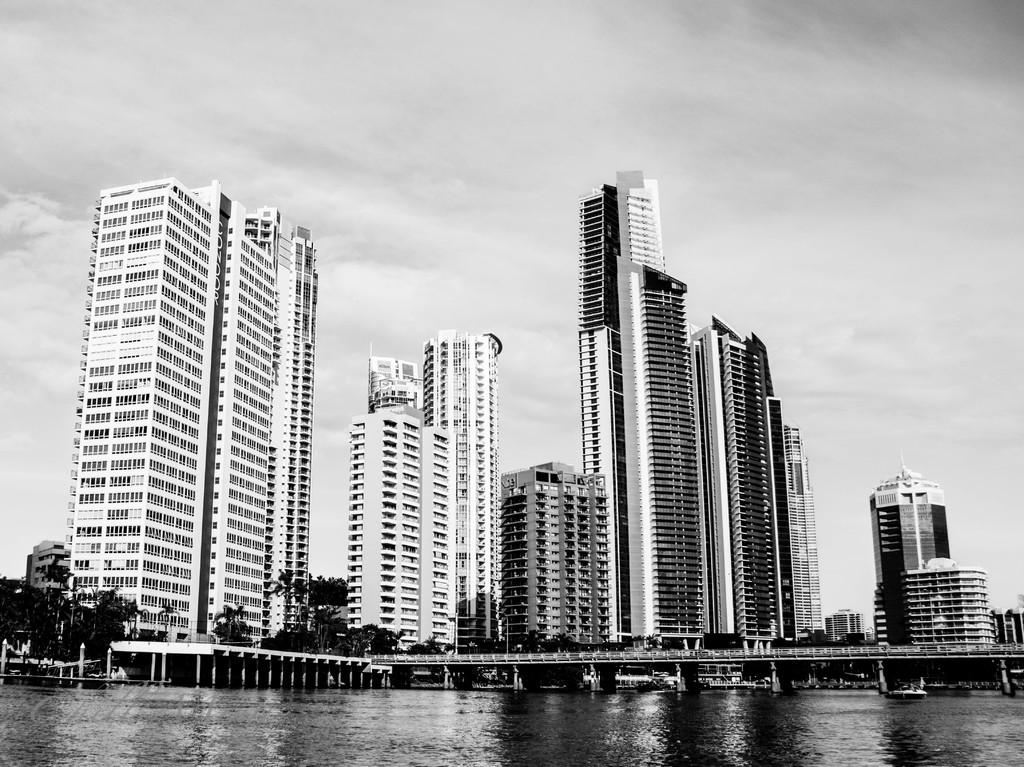What type of structures can be seen in the image? There are buildings in the image. What is located at the bottom of the image? There is water visible at the bottom of the image. What mode of transportation is present in the image? There is a boat in the image. What type of vegetation can be seen in the image? There are trees in the image. What is visible at the top of the image? The sky is visible at the top of the image. How many sheep are present in the image? There are no sheep present in the image. What type of cream is being used to paint the buildings in the image? There is no cream being used to paint the buildings in the image; the buildings are not being painted. 